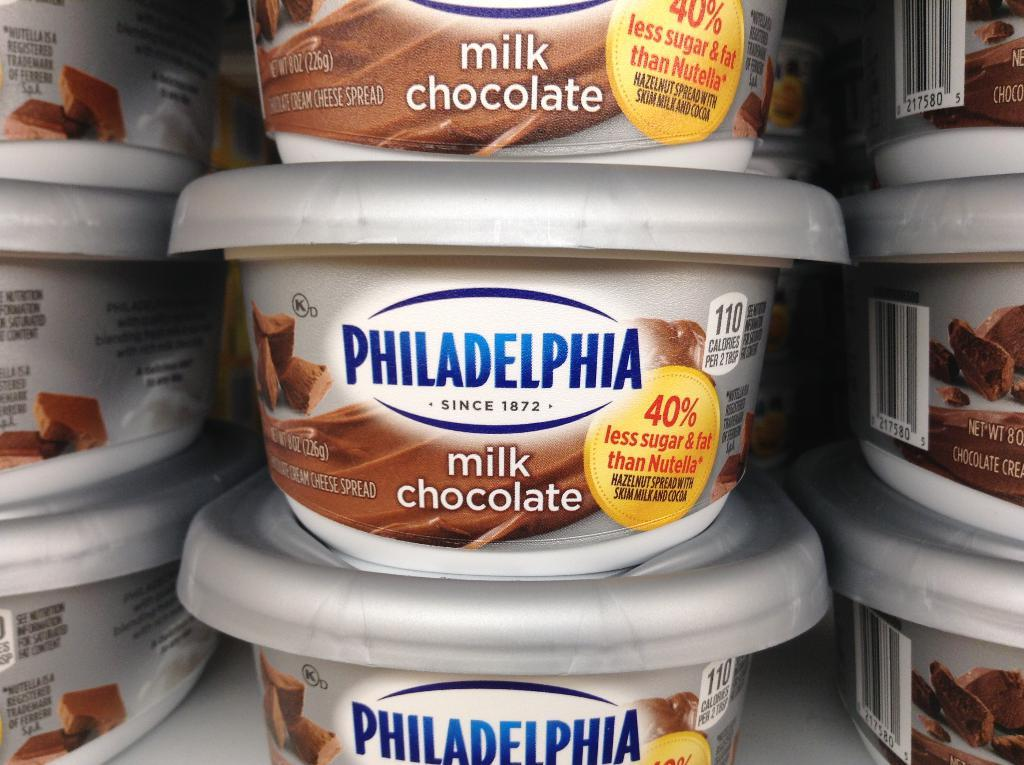What type of chocolate is featured in the image? There are milk chocolate boxes in the image. What colors are the milk chocolate boxes? The milk chocolate boxes are in white and brown color. On what surface are the milk chocolate boxes placed? The milk chocolate boxes are on a white color surface. What type of leather is visible on the army uniforms in the image? There are no army uniforms or leather in the image; it features milk chocolate boxes on a white surface. 